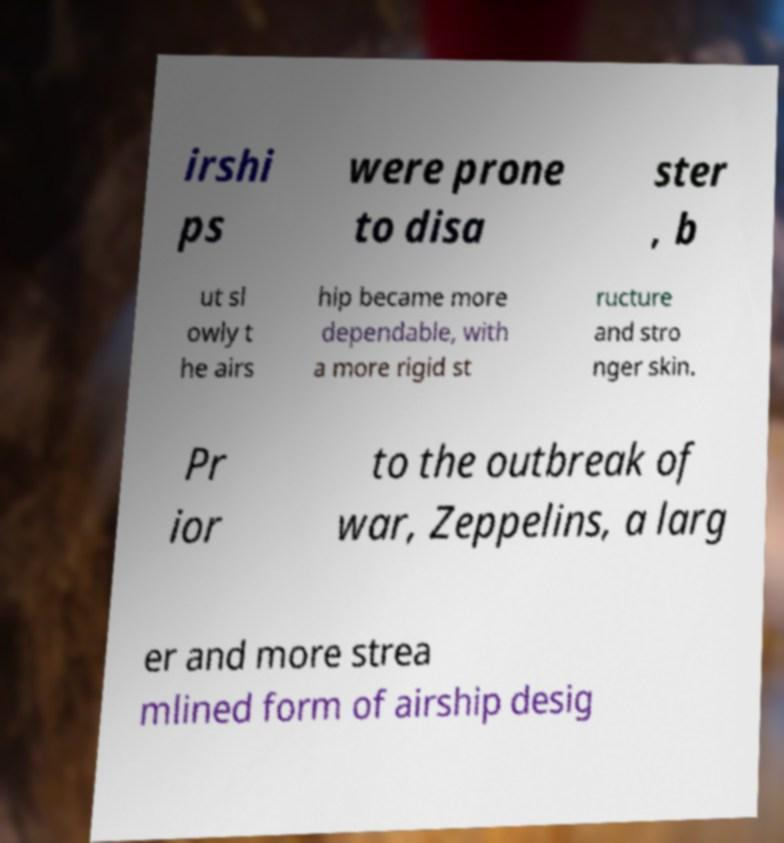Please read and relay the text visible in this image. What does it say? irshi ps were prone to disa ster , b ut sl owly t he airs hip became more dependable, with a more rigid st ructure and stro nger skin. Pr ior to the outbreak of war, Zeppelins, a larg er and more strea mlined form of airship desig 